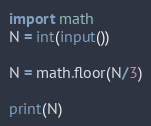<code> <loc_0><loc_0><loc_500><loc_500><_Python_>import math
N = int(input())

N = math.floor(N/3)

print(N)
</code> 